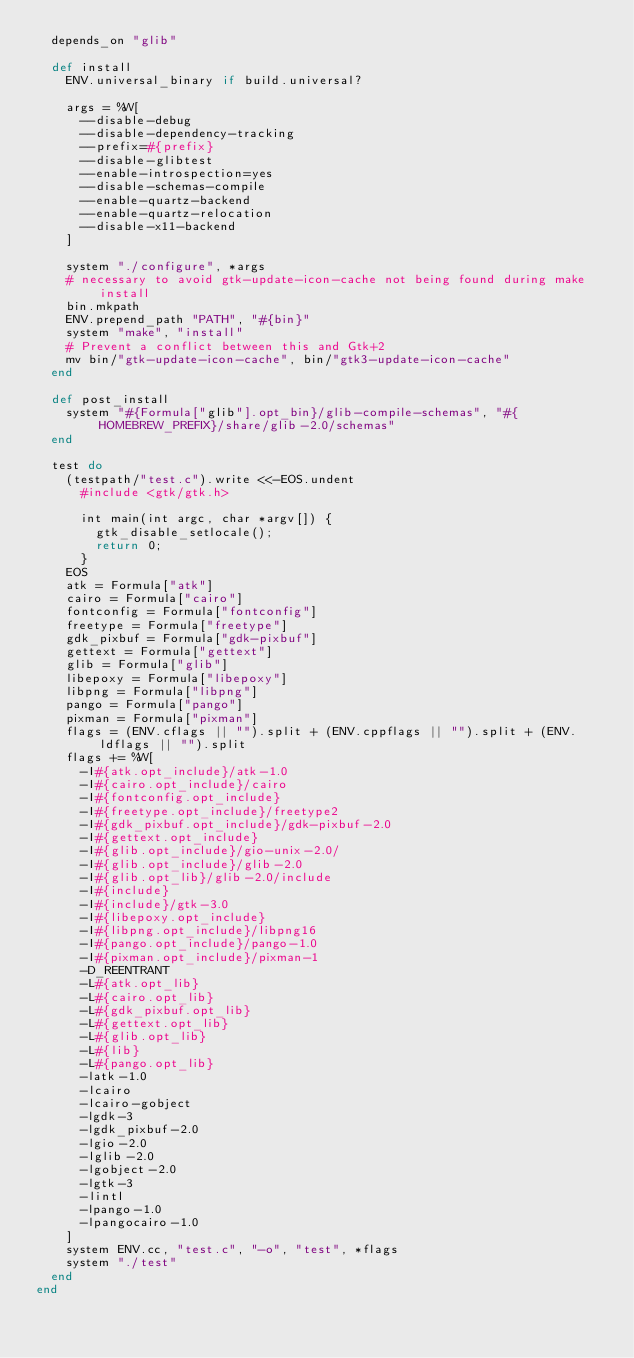<code> <loc_0><loc_0><loc_500><loc_500><_Ruby_>  depends_on "glib"

  def install
    ENV.universal_binary if build.universal?

    args = %W[
      --disable-debug
      --disable-dependency-tracking
      --prefix=#{prefix}
      --disable-glibtest
      --enable-introspection=yes
      --disable-schemas-compile
      --enable-quartz-backend
      --enable-quartz-relocation
      --disable-x11-backend
    ]

    system "./configure", *args
    # necessary to avoid gtk-update-icon-cache not being found during make install
    bin.mkpath
    ENV.prepend_path "PATH", "#{bin}"
    system "make", "install"
    # Prevent a conflict between this and Gtk+2
    mv bin/"gtk-update-icon-cache", bin/"gtk3-update-icon-cache"
  end

  def post_install
    system "#{Formula["glib"].opt_bin}/glib-compile-schemas", "#{HOMEBREW_PREFIX}/share/glib-2.0/schemas"
  end

  test do
    (testpath/"test.c").write <<-EOS.undent
      #include <gtk/gtk.h>

      int main(int argc, char *argv[]) {
        gtk_disable_setlocale();
        return 0;
      }
    EOS
    atk = Formula["atk"]
    cairo = Formula["cairo"]
    fontconfig = Formula["fontconfig"]
    freetype = Formula["freetype"]
    gdk_pixbuf = Formula["gdk-pixbuf"]
    gettext = Formula["gettext"]
    glib = Formula["glib"]
    libepoxy = Formula["libepoxy"]
    libpng = Formula["libpng"]
    pango = Formula["pango"]
    pixman = Formula["pixman"]
    flags = (ENV.cflags || "").split + (ENV.cppflags || "").split + (ENV.ldflags || "").split
    flags += %W[
      -I#{atk.opt_include}/atk-1.0
      -I#{cairo.opt_include}/cairo
      -I#{fontconfig.opt_include}
      -I#{freetype.opt_include}/freetype2
      -I#{gdk_pixbuf.opt_include}/gdk-pixbuf-2.0
      -I#{gettext.opt_include}
      -I#{glib.opt_include}/gio-unix-2.0/
      -I#{glib.opt_include}/glib-2.0
      -I#{glib.opt_lib}/glib-2.0/include
      -I#{include}
      -I#{include}/gtk-3.0
      -I#{libepoxy.opt_include}
      -I#{libpng.opt_include}/libpng16
      -I#{pango.opt_include}/pango-1.0
      -I#{pixman.opt_include}/pixman-1
      -D_REENTRANT
      -L#{atk.opt_lib}
      -L#{cairo.opt_lib}
      -L#{gdk_pixbuf.opt_lib}
      -L#{gettext.opt_lib}
      -L#{glib.opt_lib}
      -L#{lib}
      -L#{pango.opt_lib}
      -latk-1.0
      -lcairo
      -lcairo-gobject
      -lgdk-3
      -lgdk_pixbuf-2.0
      -lgio-2.0
      -lglib-2.0
      -lgobject-2.0
      -lgtk-3
      -lintl
      -lpango-1.0
      -lpangocairo-1.0
    ]
    system ENV.cc, "test.c", "-o", "test", *flags
    system "./test"
  end
end
</code> 